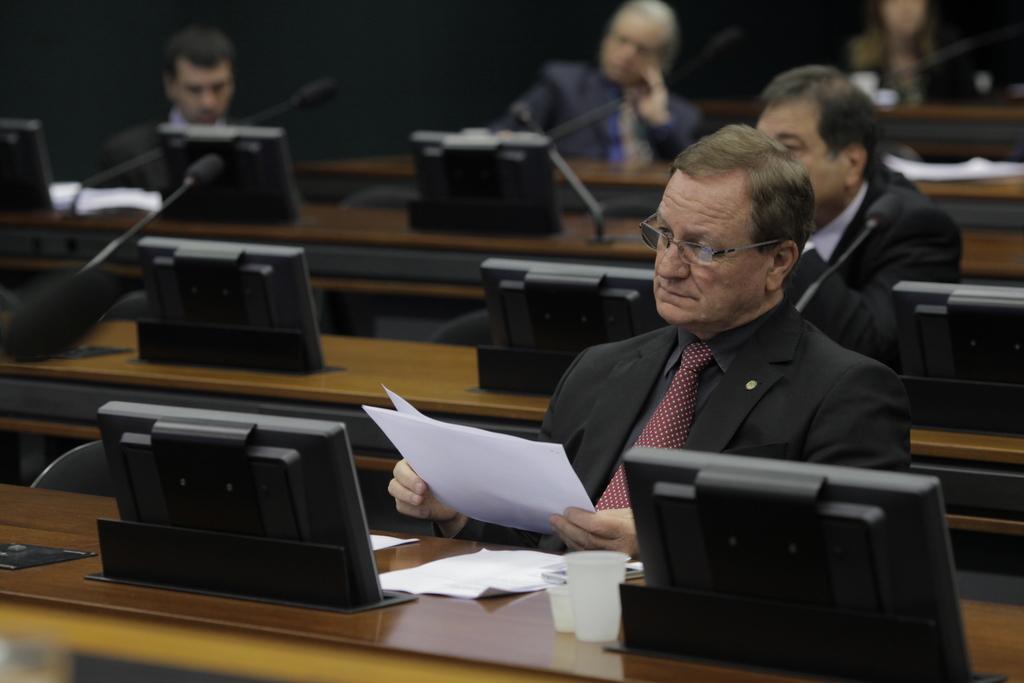Could you give a brief overview of what you see in this image? In this image we can see men sitting on the chairs and tables are placed in front of them. On the tables we can see desktops, glass tumblers and papers. 